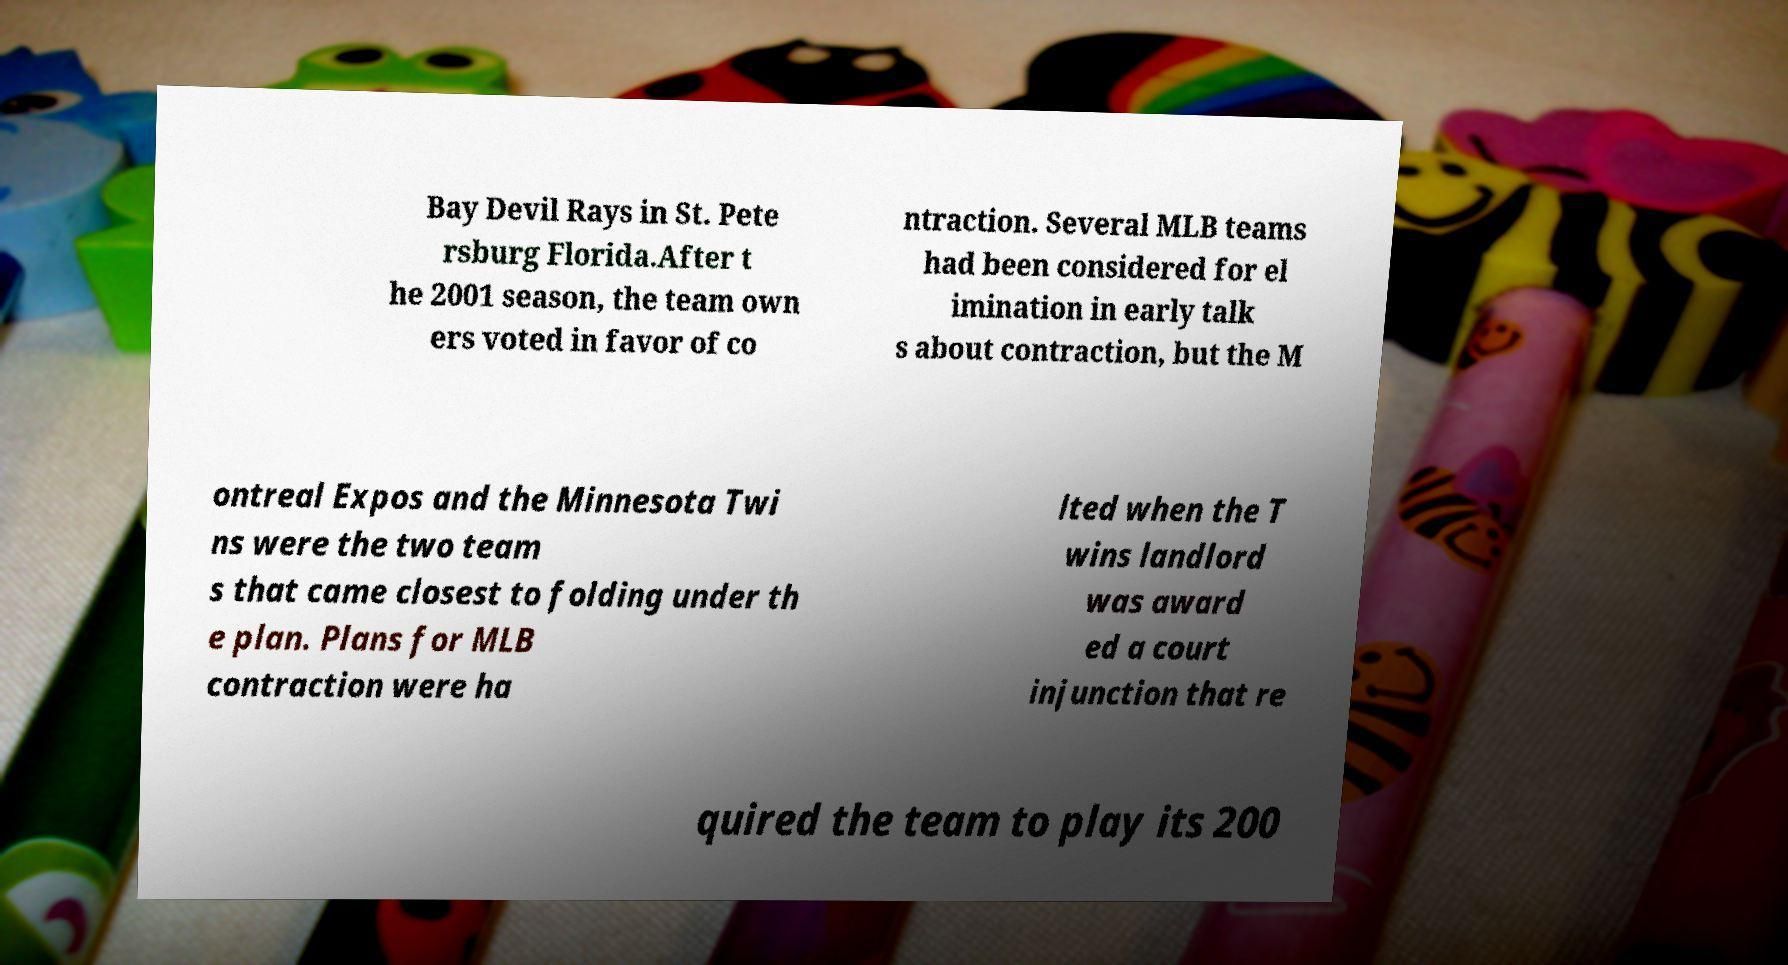Please read and relay the text visible in this image. What does it say? Bay Devil Rays in St. Pete rsburg Florida.After t he 2001 season, the team own ers voted in favor of co ntraction. Several MLB teams had been considered for el imination in early talk s about contraction, but the M ontreal Expos and the Minnesota Twi ns were the two team s that came closest to folding under th e plan. Plans for MLB contraction were ha lted when the T wins landlord was award ed a court injunction that re quired the team to play its 200 